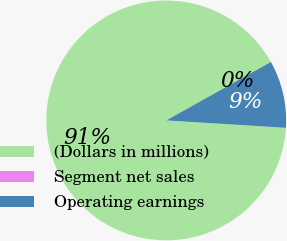Convert chart. <chart><loc_0><loc_0><loc_500><loc_500><pie_chart><fcel>(Dollars in millions)<fcel>Segment net sales<fcel>Operating earnings<nl><fcel>90.91%<fcel>0.0%<fcel>9.09%<nl></chart> 